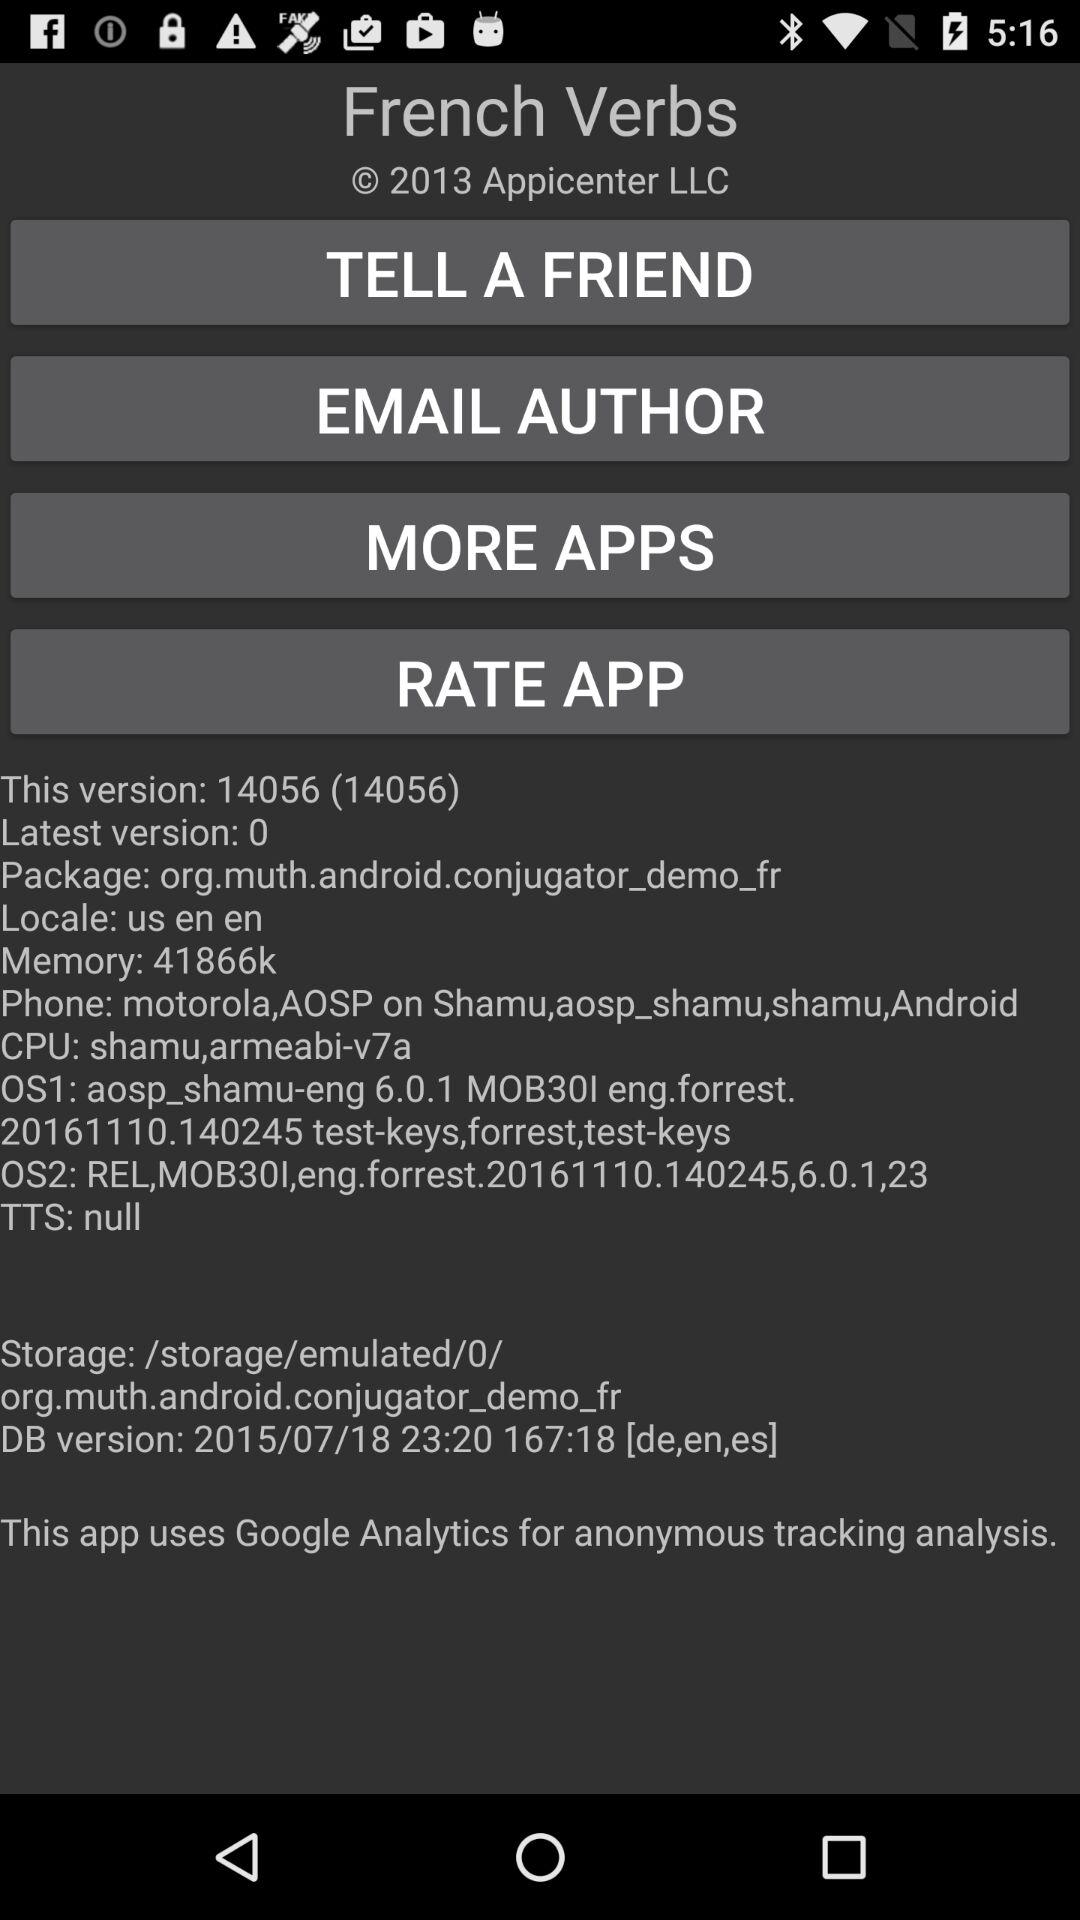How much is the "Memory" space? The memory space is 41866k. 